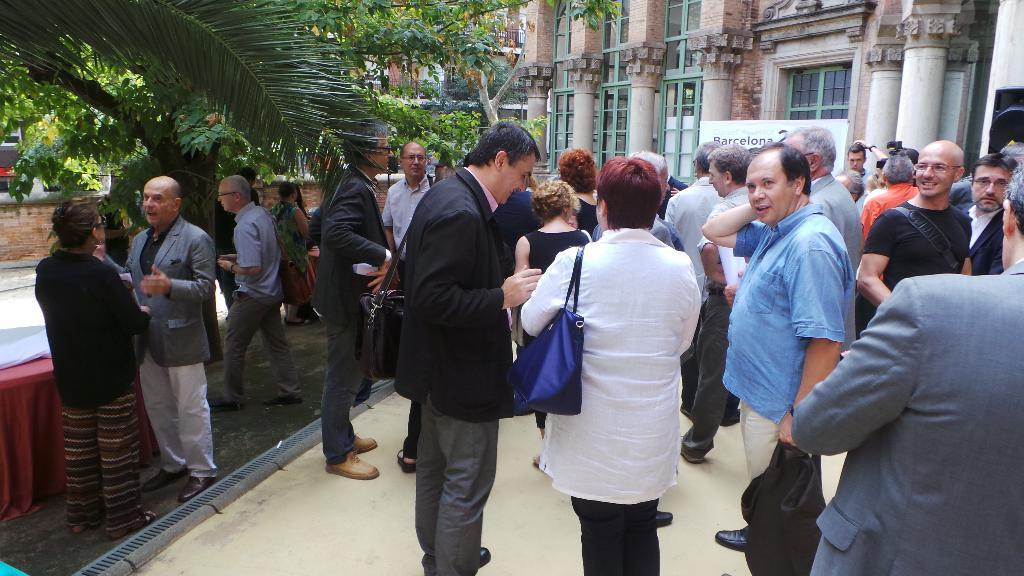What is happening in the center of the image? There are people standing in the center of the image. What can be seen in the distance behind the people? There are buildings in the background of the image. What is the board visible in the background used for? The purpose of the board visible in the background is not specified in the facts. What type of vegetation is on the left side of the image? There are trees on the left side of the image. What object can be used for placing items on in the image? There is a table in the image. How many rings are visible on the fingers of the people in the image? There is no information about rings or fingers in the provided facts, so it cannot be determined from the image. 